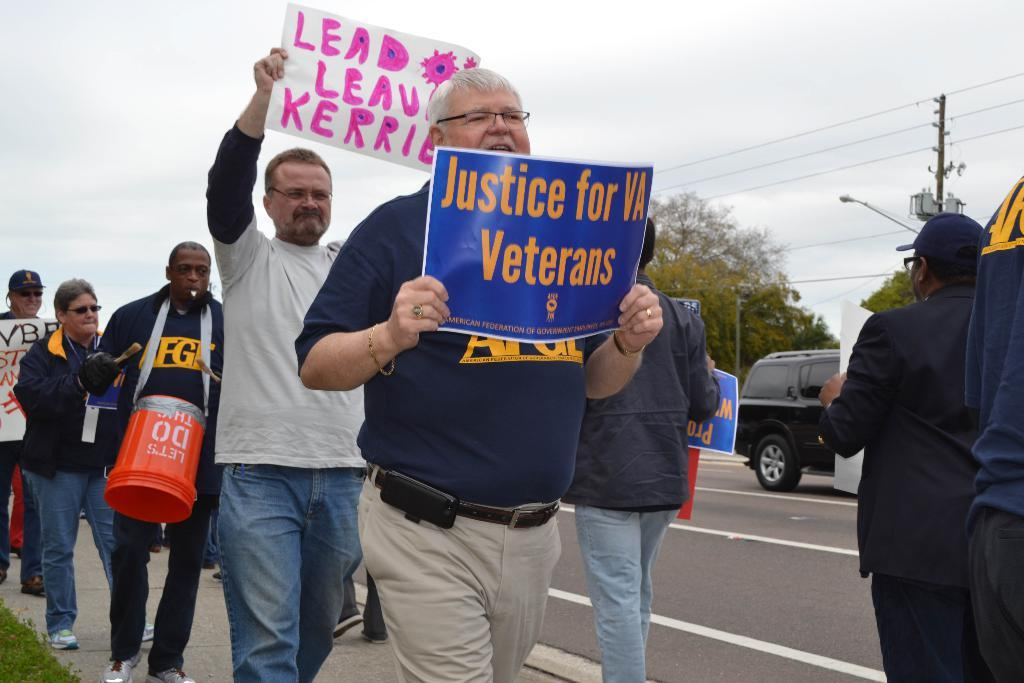Who or what is present in the image? There are persons in the image. What are the persons holding in the image? The persons are holding posters. What can be seen on the road in the image? There is a car on the road. What is visible in the background of the image? There are trees, a pole, and the sky visible in the background of the image. What type of scent can be smelled coming from the pole in the image? There is no indication of a scent in the image, and the pole does not have any visible source of scent. 